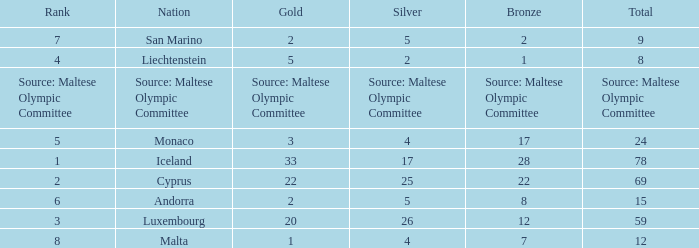What is the total medal count for the nation that has 5 gold? 8.0. 